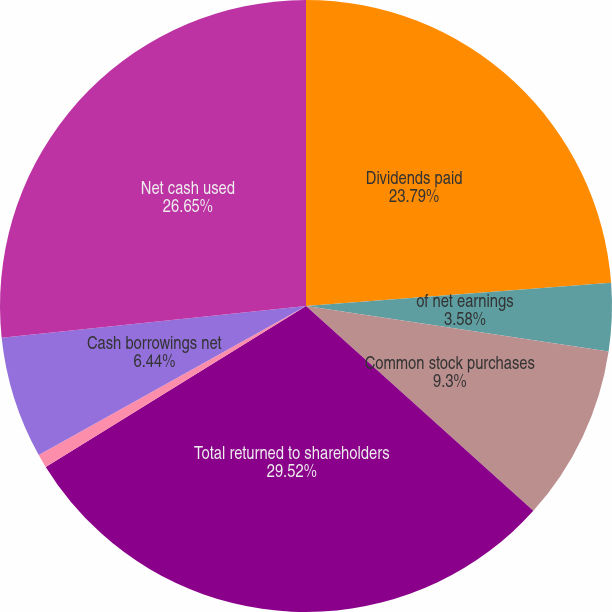<chart> <loc_0><loc_0><loc_500><loc_500><pie_chart><fcel>Dividends paid<fcel>of net earnings<fcel>Common stock purchases<fcel>Total returned to shareholders<fcel>Proceeds from the exercise of<fcel>Cash borrowings net<fcel>Net cash used<nl><fcel>23.79%<fcel>3.58%<fcel>9.3%<fcel>29.51%<fcel>0.72%<fcel>6.44%<fcel>26.65%<nl></chart> 